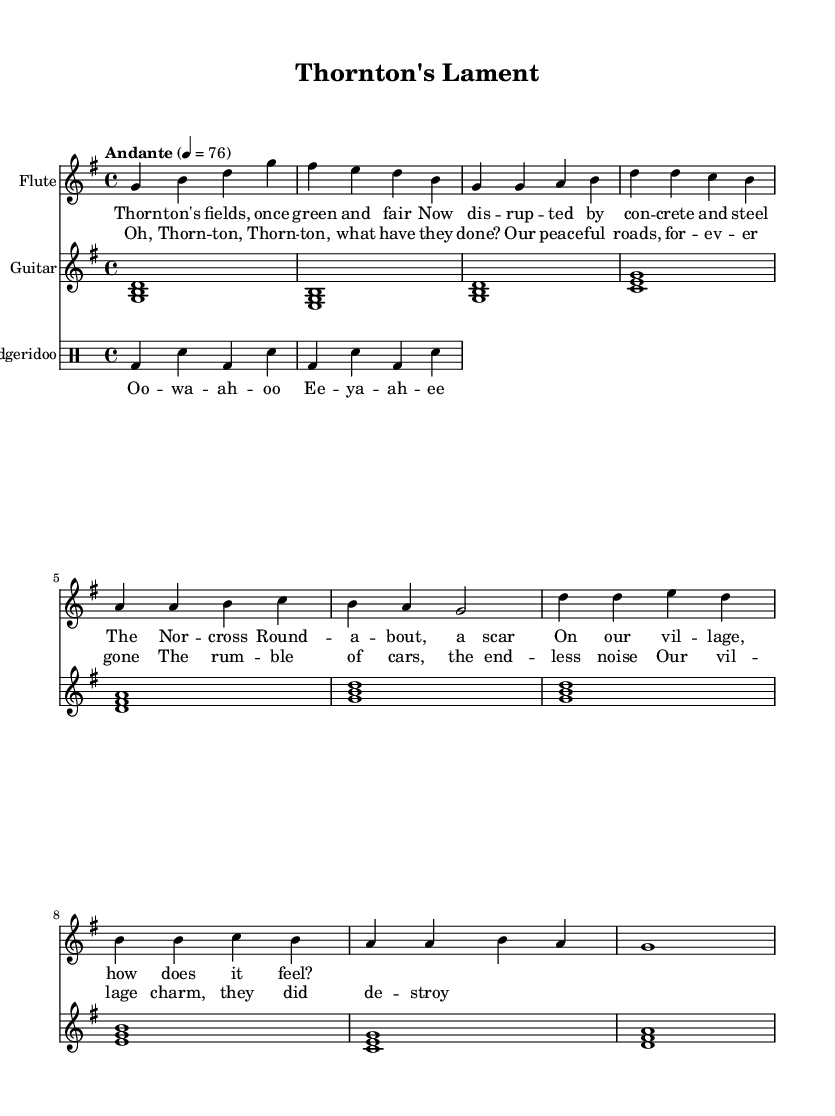What is the key signature of this music? The key signature is indicated in the global section of the code as G major, which has one sharp (F sharp).
Answer: G major What is the time signature of this music? The time signature is also found in the global section, represented as 4/4. This means there are four beats in each measure and a quarter note receives one beat.
Answer: 4/4 What is the tempo marking for this music? The tempo marking is specified as "Andante" with a metronome marking of 76, indicating a moderate speed for the piece.
Answer: Andante How many measures are there in the flute part? Count the number of measures in the flute section; the notation reveals there are a total of 8 measures.
Answer: 8 Which musical element is used to create a rhythmic pattern for the didgeridoo? The didgeridoo uses a drummode pattern which consists of bass drums (bd) and snare (sn) notes to create its rhythmic texture.
Answer: Drummode What is the primary theme conveyed in the lyrics of the verse? The verse lyrics reflect emotions about the changes in the village, expressing regret over the loss of its charm due to construction, particularly linked to the Norcross Roundabout.
Answer: Regret over village changes What cultural music elements are blended in this piece? The piece blends traditional Australian elements such as the didgeridoo and Aboriginal chants with pastoral melodies typical of English folk music, creating a cross-cultural musical expression.
Answer: Cross-cultural blend 